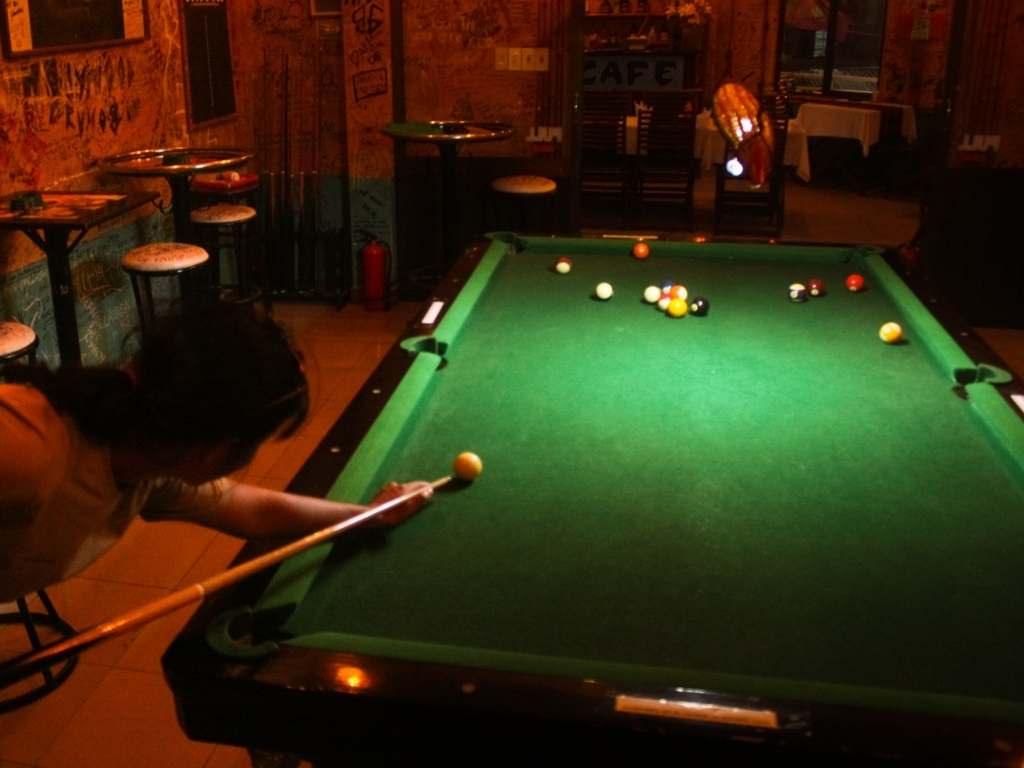Can you describe the activity taking place in the image? A person appears to be taking a shot at a game of pool. The positioning of the balls suggests the game is in mid-play. The focused stance of the player indicates concentration and an attempt to make a precise shot. 